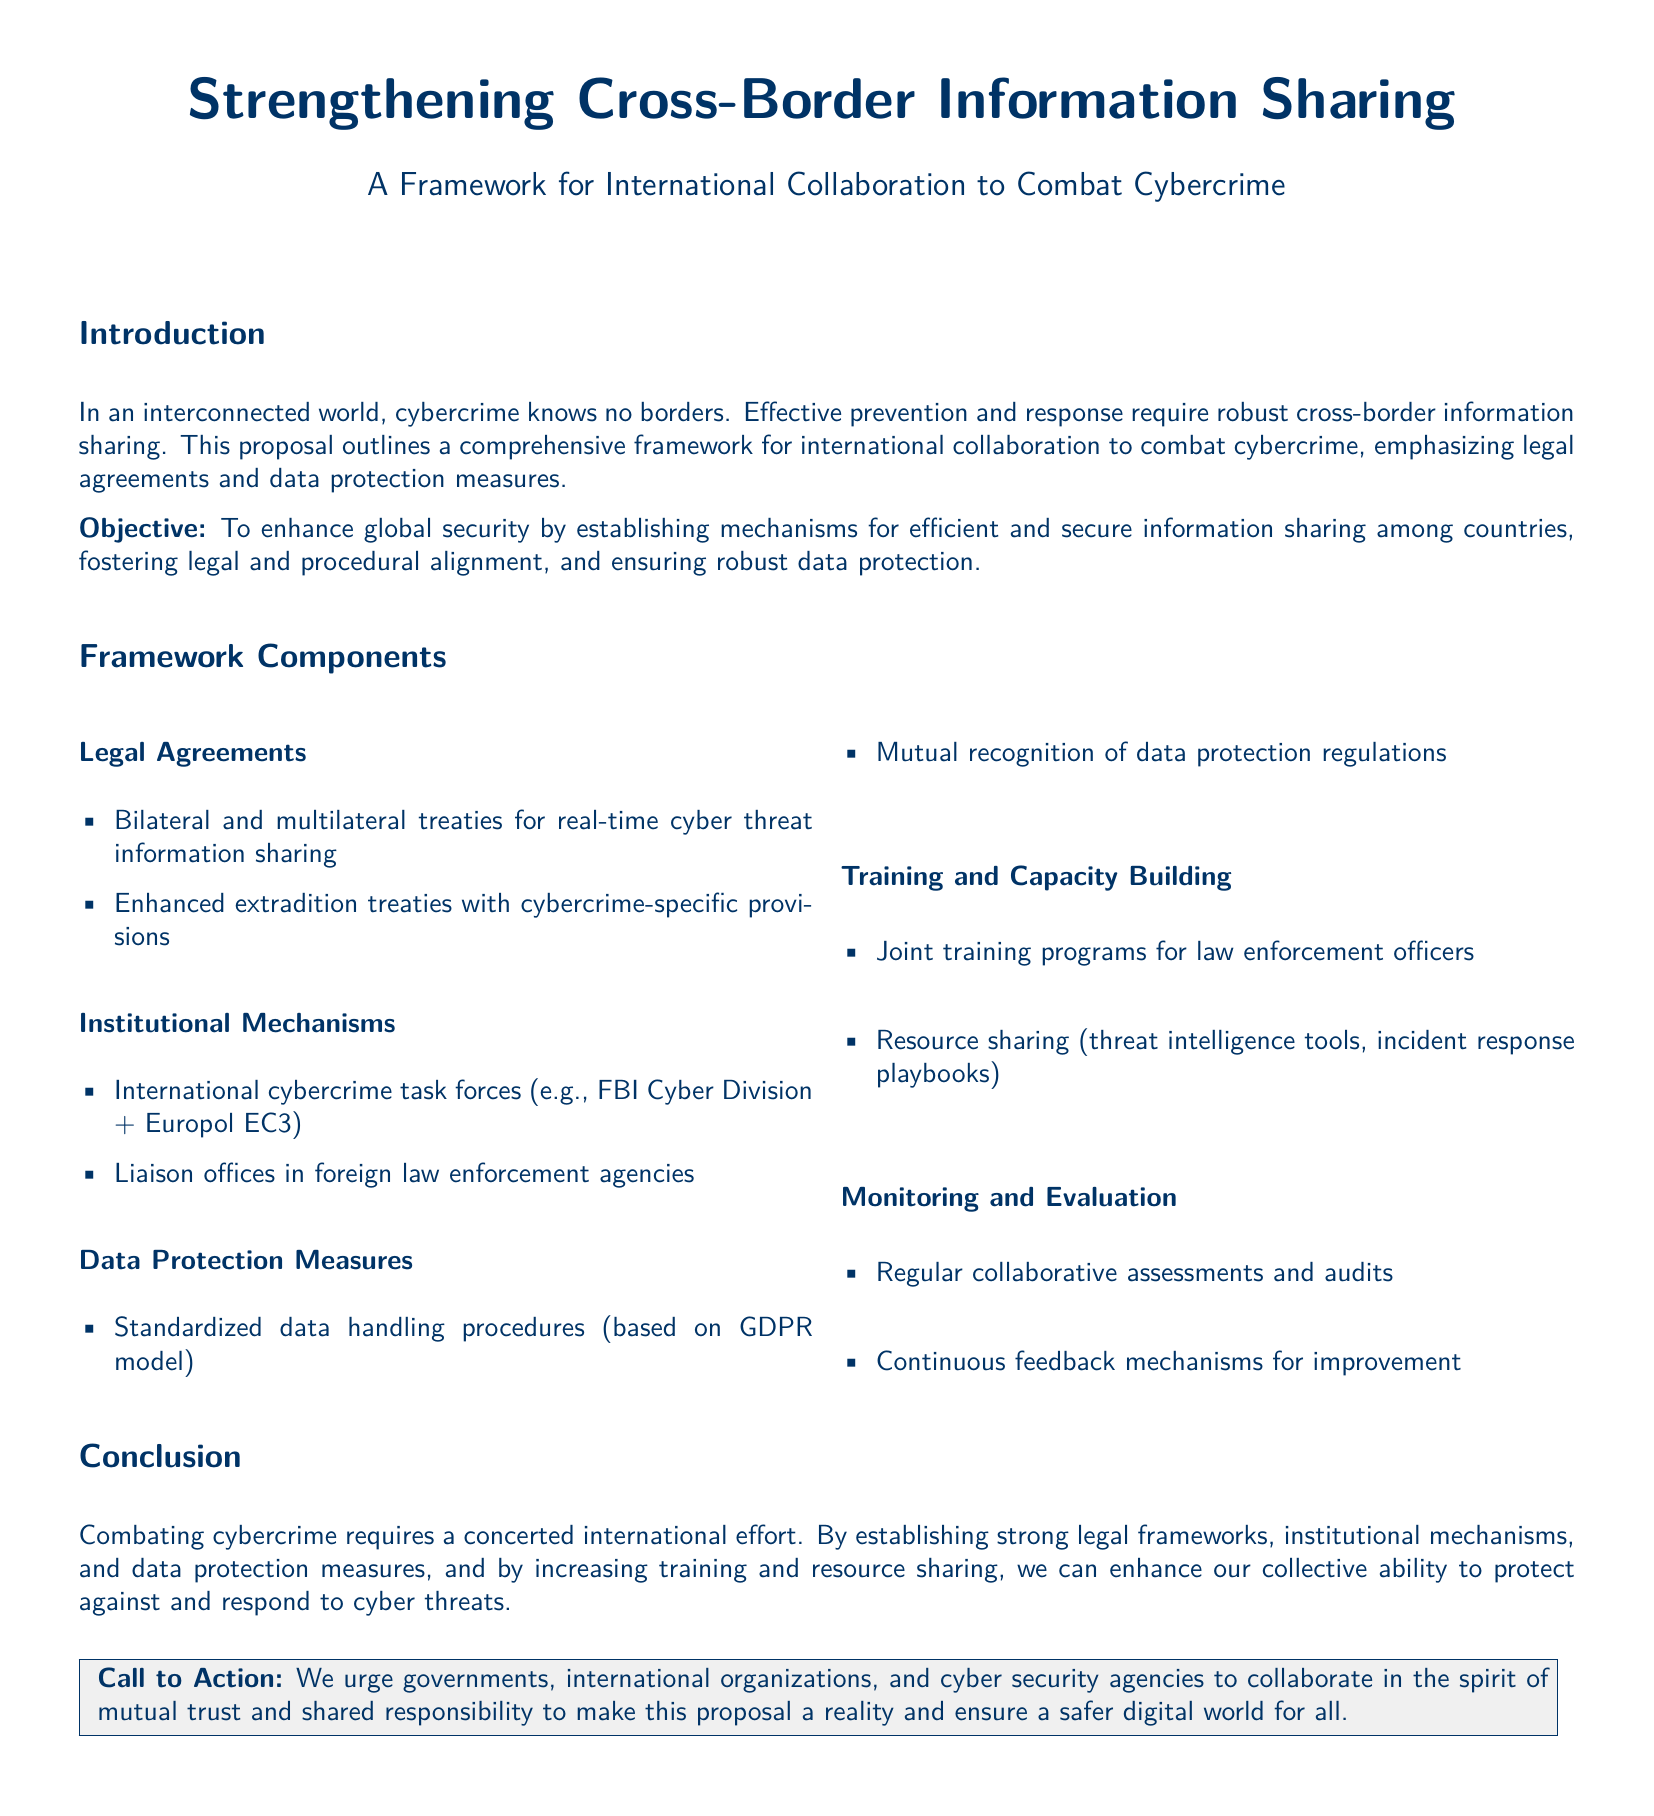what is the title of the proposal? The title of the proposal indicates the main focus of the document, which is strengthening collaboration against cybercrime.
Answer: Strengthening Cross-Border Information Sharing what is the objective of the proposal? The objective outlines the primary goal of the proposal, focusing on enhancing global security through collaboration.
Answer: To enhance global security what are the two types of legal agreements mentioned? The proposal specifies different legal frameworks needed for cooperation in cybercrime prevention.
Answer: Bilateral and multilateral treaties name one institutional mechanism mentioned in the framework. The proposal lists organizational structures that aid in international collaboration against cybercrime.
Answer: International cybercrime task forces which data protection model is referenced in the proposal? The proposal refers to an established framework for data handling to ensure protection standards.
Answer: GDPR model what type of training does the proposal advocate for? The proposal emphasizes the importance of training to improve law enforcement capabilities globally.
Answer: Joint training programs how many components are listed in the framework? Counting the distinct sections provided in the framework gives the total components included.
Answer: Five what is included in the monitoring and evaluation component? This section describes how the effectiveness of the proposed measures will be assessed.
Answer: Regular collaborative assessments what is the call to action directed towards? The call to action specifies the groups that are encouraged to collaborate for achieving the proposal goals.
Answer: Governments, international organizations, and cyber security agencies 